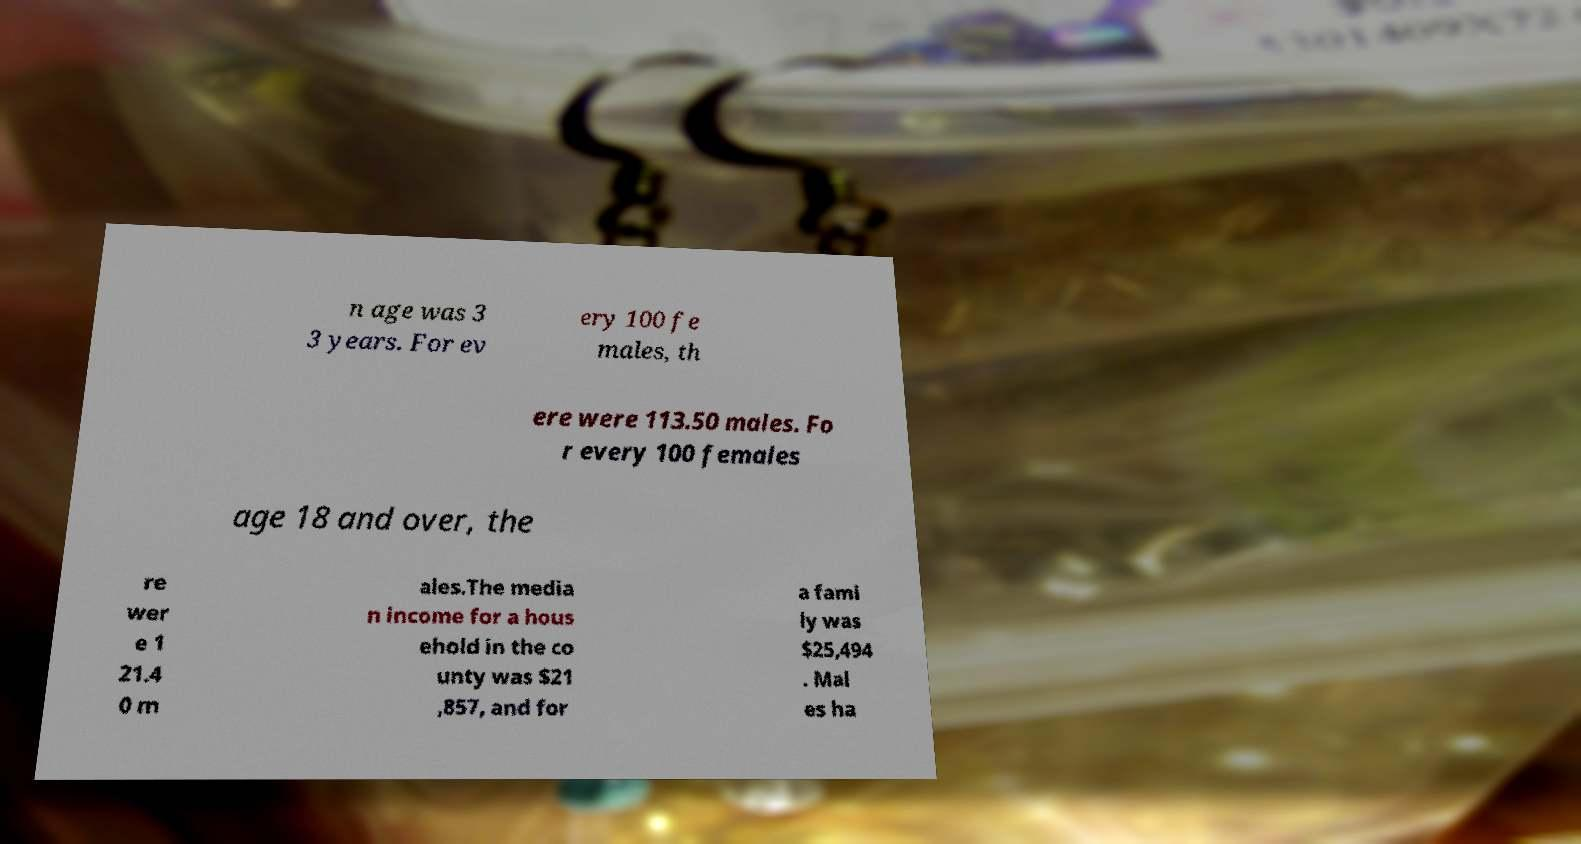Could you extract and type out the text from this image? n age was 3 3 years. For ev ery 100 fe males, th ere were 113.50 males. Fo r every 100 females age 18 and over, the re wer e 1 21.4 0 m ales.The media n income for a hous ehold in the co unty was $21 ,857, and for a fami ly was $25,494 . Mal es ha 